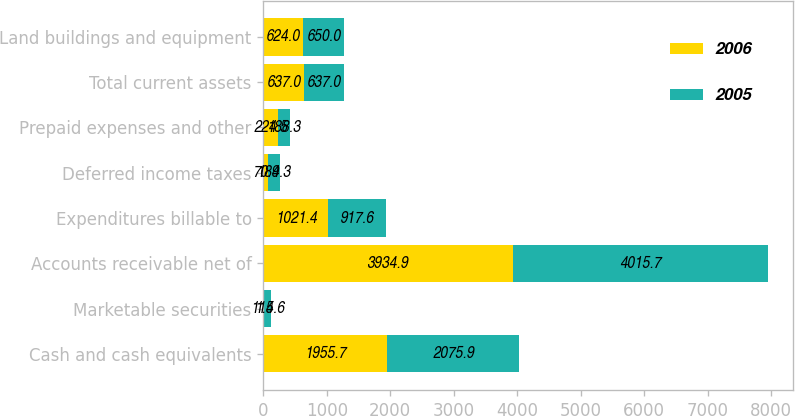<chart> <loc_0><loc_0><loc_500><loc_500><stacked_bar_chart><ecel><fcel>Cash and cash equivalents<fcel>Marketable securities<fcel>Accounts receivable net of<fcel>Expenditures billable to<fcel>Deferred income taxes<fcel>Prepaid expenses and other<fcel>Total current assets<fcel>Land buildings and equipment<nl><fcel>2006<fcel>1955.7<fcel>1.4<fcel>3934.9<fcel>1021.4<fcel>70.9<fcel>224.5<fcel>637<fcel>624<nl><fcel>2005<fcel>2075.9<fcel>115.6<fcel>4015.7<fcel>917.6<fcel>184.3<fcel>188.3<fcel>637<fcel>650<nl></chart> 